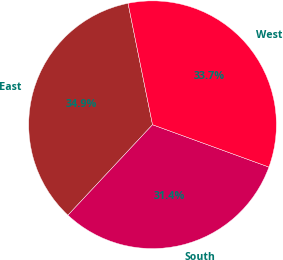<chart> <loc_0><loc_0><loc_500><loc_500><pie_chart><fcel>East<fcel>South<fcel>West<nl><fcel>34.87%<fcel>31.41%<fcel>33.72%<nl></chart> 